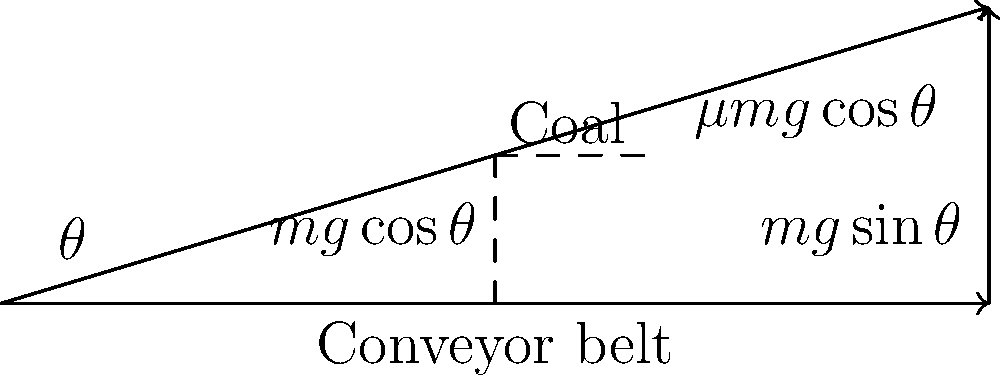A coal transportation system uses an inclined conveyor belt. To minimize energy consumption while ensuring the coal doesn't slide back down, you need to determine the optimal angle for the conveyor belt. Given that the coefficient of static friction between the coal and the belt is 0.3, calculate the optimal angle (in degrees) for the inclined conveyor belt. To find the optimal angle, we need to consider the forces acting on the coal:

1. The force of gravity: $mg$
2. The normal force: $N = mg\cos\theta$
3. The friction force: $f = \mu N = \mu mg\cos\theta$

For the coal to be on the verge of sliding (optimal condition):

$f = mg\sin\theta$

Substituting the friction force:

$\mu mg\cos\theta = mg\sin\theta$

Simplifying:

$\mu \cos\theta = \sin\theta$

Dividing both sides by $\cos\theta$:

$\mu = \tan\theta$

Therefore, the optimal angle is:

$\theta = \arctan(\mu)$

Given $\mu = 0.3$:

$\theta = \arctan(0.3)$

Converting to degrees:

$\theta = \arctan(0.3) \cdot \frac{180}{\pi} \approx 16.7°$
Answer: 16.7° 